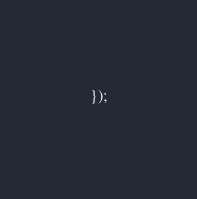<code> <loc_0><loc_0><loc_500><loc_500><_JavaScript_>});</code> 